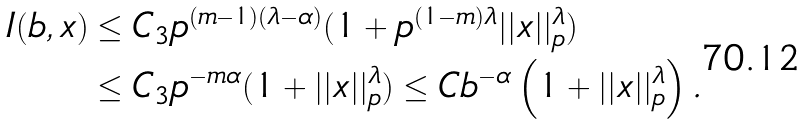Convert formula to latex. <formula><loc_0><loc_0><loc_500><loc_500>I ( b , x ) & \leq C _ { 3 } p ^ { ( m - 1 ) ( \lambda - \alpha ) } ( 1 + p ^ { ( 1 - m ) \lambda } | | x | | _ { p } ^ { \lambda } ) \\ & \leq C _ { 3 } p ^ { - m \alpha } ( 1 + | | x | | _ { p } ^ { \lambda } ) \leq C b ^ { - \alpha } \left ( 1 + | | x | | _ { p } ^ { \lambda } \right ) .</formula> 